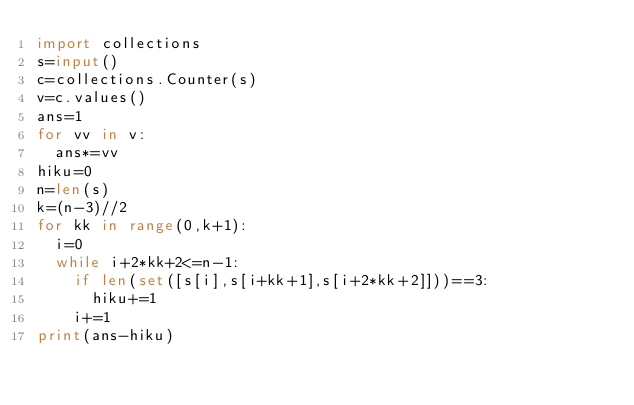Convert code to text. <code><loc_0><loc_0><loc_500><loc_500><_Python_>import collections
s=input()
c=collections.Counter(s)
v=c.values()
ans=1
for vv in v:
  ans*=vv
hiku=0
n=len(s)
k=(n-3)//2
for kk in range(0,k+1):
  i=0
  while i+2*kk+2<=n-1:
    if len(set([s[i],s[i+kk+1],s[i+2*kk+2]]))==3:
      hiku+=1
    i+=1
print(ans-hiku)</code> 